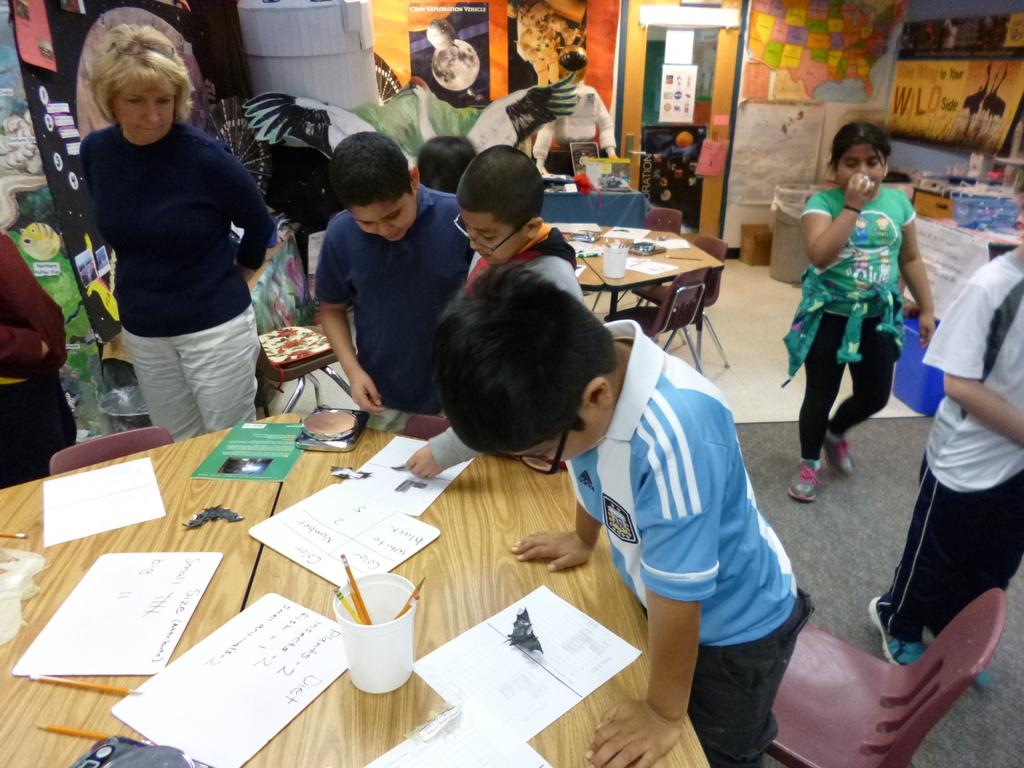What can be seen on the walls in the image? There are posters in the image. Who or what is present in the image? There are people in the image. What piece of furniture is visible in the image? There is a table in the image. What items are on the table in the image? There are papers, pencils, and a glass on the table. Can you tell me where the zebra is located in the image? There is no zebra present in the image. Is there a camera visible in the image? There is no camera visible in the image. 